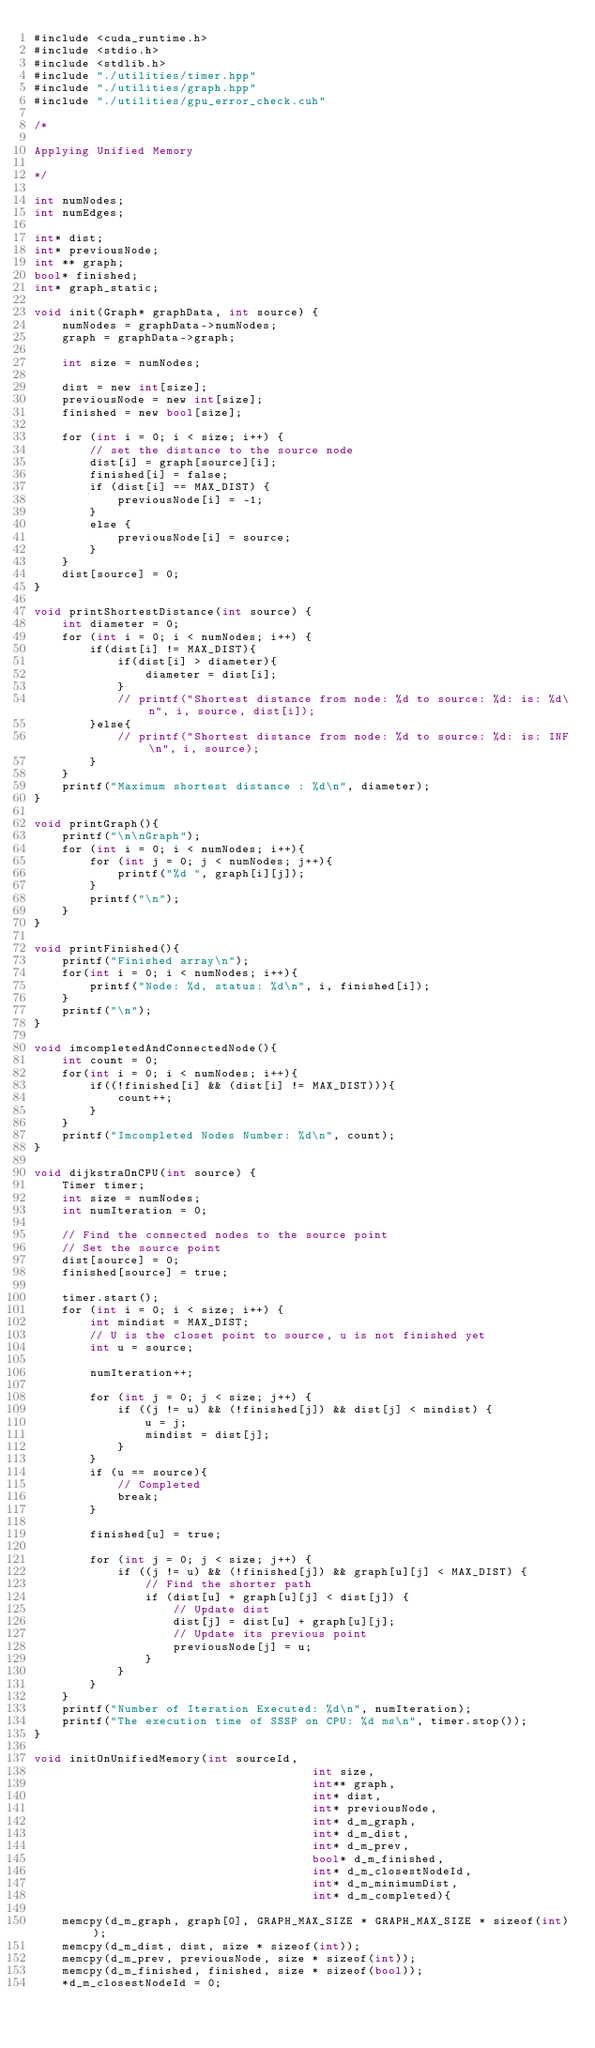<code> <loc_0><loc_0><loc_500><loc_500><_Cuda_>#include <cuda_runtime.h>
#include <stdio.h>
#include <stdlib.h>
#include "./utilities/timer.hpp"
#include "./utilities/graph.hpp"
#include "./utilities/gpu_error_check.cuh"

/*

Applying Unified Memory

*/

int numNodes;
int numEdges;

int* dist;
int* previousNode;
int ** graph;
bool* finished;
int* graph_static;

void init(Graph* graphData, int source) {
    numNodes = graphData->numNodes;
    graph = graphData->graph;

    int size = numNodes;

    dist = new int[size];
    previousNode = new int[size];
    finished = new bool[size];

    for (int i = 0; i < size; i++) {
        // set the distance to the source node
        dist[i] = graph[source][i];
        finished[i] = false;
        if (dist[i] == MAX_DIST) {
            previousNode[i] = -1;
        }
        else {
            previousNode[i] = source;
        }
    }
    dist[source] = 0;
}

void printShortestDistance(int source) {
    int diameter = 0;
    for (int i = 0; i < numNodes; i++) {
        if(dist[i] != MAX_DIST){
            if(dist[i] > diameter){
                diameter = dist[i];
            }
            // printf("Shortest distance from node: %d to source: %d: is: %d\n", i, source, dist[i]);
        }else{
            // printf("Shortest distance from node: %d to source: %d: is: INF\n", i, source);
        } 
    }
    printf("Maximum shortest distance : %d\n", diameter);
}

void printGraph(){
    printf("\n\nGraph");
    for (int i = 0; i < numNodes; i++){
        for (int j = 0; j < numNodes; j++){
            printf("%d ", graph[i][j]);
        }
        printf("\n");
    }
}

void printFinished(){
    printf("Finished array\n");
    for(int i = 0; i < numNodes; i++){
        printf("Node: %d, status: %d\n", i, finished[i]);
    }
    printf("\n");
}

void imcompletedAndConnectedNode(){
    int count = 0;
    for(int i = 0; i < numNodes; i++){
        if((!finished[i] && (dist[i] != MAX_DIST))){
            count++;
        }
    }
    printf("Imcompleted Nodes Number: %d\n", count);
}

void dijkstraOnCPU(int source) {
    Timer timer;
    int size = numNodes;
    int numIteration = 0;
    
    // Find the connected nodes to the source point
    // Set the source point
    dist[source] = 0;
    finished[source] = true;

    timer.start();
    for (int i = 0; i < size; i++) {
        int mindist = MAX_DIST;
        // U is the closet point to source, u is not finished yet
        int u = source;

        numIteration++;

        for (int j = 0; j < size; j++) {
            if ((j != u) && (!finished[j]) && dist[j] < mindist) {
                u = j;
                mindist = dist[j];
            }
        }
        if (u == source){
            // Completed
            break;
        }

        finished[u] = true;

        for (int j = 0; j < size; j++) {
            if ((j != u) && (!finished[j]) && graph[u][j] < MAX_DIST) {
                // Find the shorter path
                if (dist[u] + graph[u][j] < dist[j]) {
                    // Update dist
                    dist[j] = dist[u] + graph[u][j];
                    // Update its previous point
                    previousNode[j] = u;
                }
            }
        }
    }
    printf("Number of Iteration Executed: %d\n", numIteration);
    printf("The execution time of SSSP on CPU: %d ms\n", timer.stop());
}

void initOnUnifiedMemory(int sourceId,
                                        int size,
                                        int** graph,
                                        int* dist,
                                        int* previousNode,
                                        int* d_m_graph,
                                        int* d_m_dist,
                                        int* d_m_prev,
                                        bool* d_m_finished,
                                        int* d_m_closestNodeId,
                                        int* d_m_minimumDist,
                                        int* d_m_completed){

    memcpy(d_m_graph, graph[0], GRAPH_MAX_SIZE * GRAPH_MAX_SIZE * sizeof(int));
    memcpy(d_m_dist, dist, size * sizeof(int));
    memcpy(d_m_prev, previousNode, size * sizeof(int));
    memcpy(d_m_finished, finished, size * sizeof(bool));
    *d_m_closestNodeId = 0;</code> 